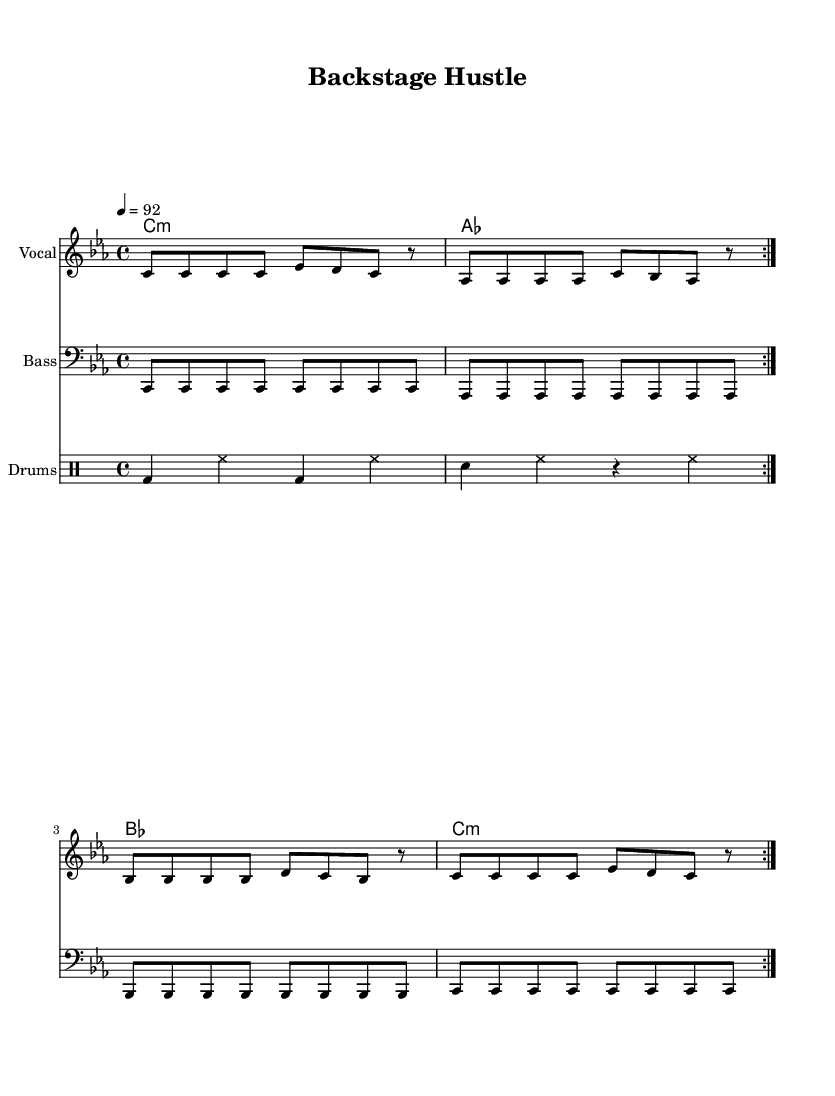What is the key signature of this music? The key signature is C minor, which has three flats (B♭, E♭, A♭). This is determined by the 'c' noted in the global context, where 'c' indicates the minor key signature.
Answer: C minor What is the time signature of the piece? The time signature is 4/4, as indicated in the global section of the music. This means there are four beats per measure, and a quarter note receives one beat.
Answer: 4/4 What is the tempo marking? The tempo marking is 92 beats per minute, as stated in the global context where "4 = 92" is shown. This indicates the speed at which the piece should be played.
Answer: 92 How many bars are in the verse section? The verse section consists of four distinct lines, each containing four measures, resulting in a total of 16 measures. The repetition of the volta also suggests that each section appears twice. Thus, the verse section has four bars.
Answer: 4 What is the main theme of the chorus? The chorus emphasizes the logistics and effort involved in tour management, conveying a theme of hard work and coordination essential for concert production. This is derived from the lyrics where phrases like "backstage hustle" and "logistics on point" are highlighted.
Answer: Backstage hustle How many different harmonic chords are used in the piece? The piece uses four different harmonic chords: C minor, A♭ major, B♭ major, and C minor again. These chords are listed in the harmonies section, where each chord appears sequentially in a single measure.
Answer: 4 What instruments are included in the score? The score includes vocals, bass, and drums, as indicated in the score sections where each staff corresponds to these instruments, showing their respective parts distinctly.
Answer: Vocal, Bass, Drums 